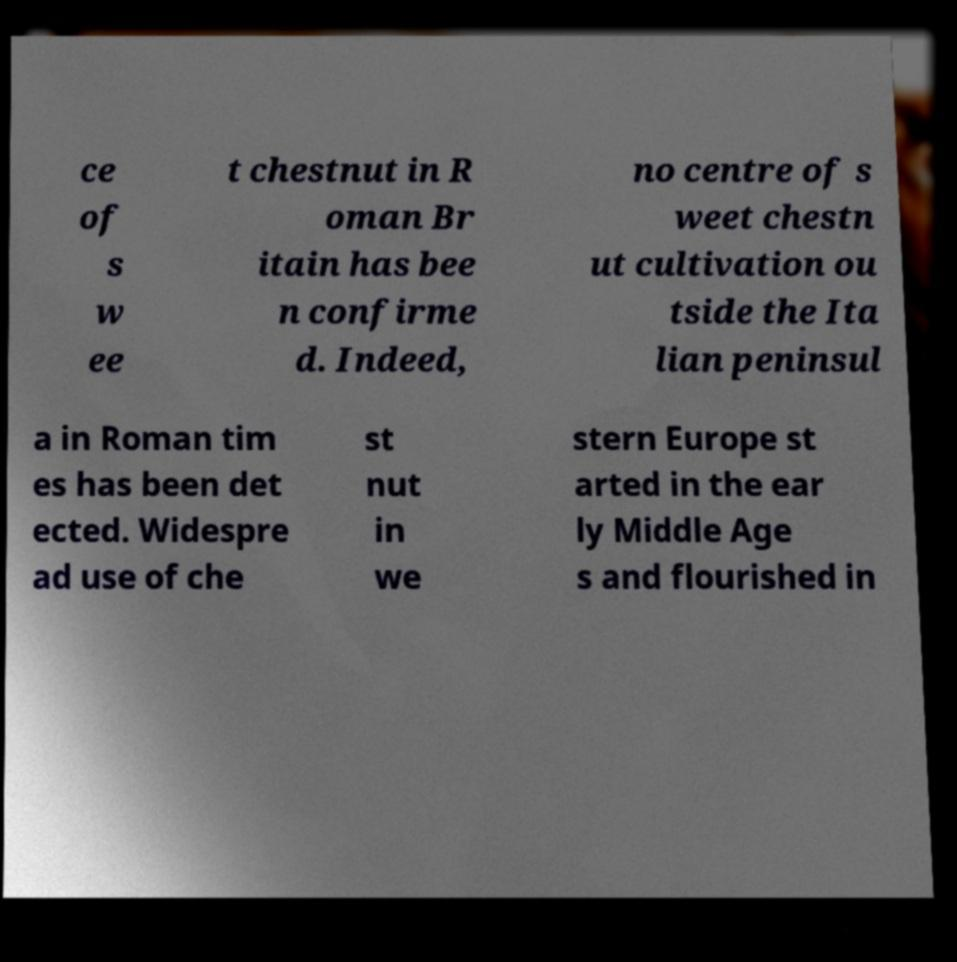There's text embedded in this image that I need extracted. Can you transcribe it verbatim? ce of s w ee t chestnut in R oman Br itain has bee n confirme d. Indeed, no centre of s weet chestn ut cultivation ou tside the Ita lian peninsul a in Roman tim es has been det ected. Widespre ad use of che st nut in we stern Europe st arted in the ear ly Middle Age s and flourished in 